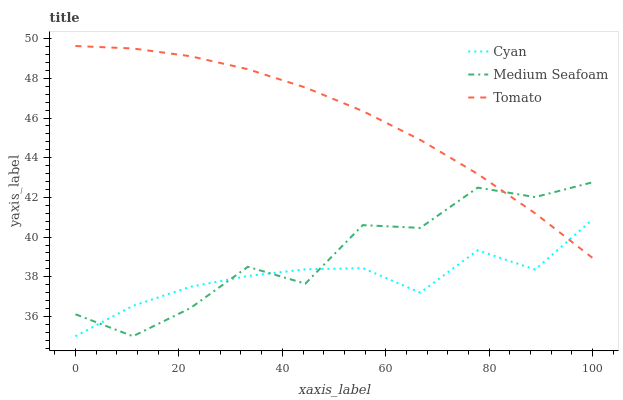Does Cyan have the minimum area under the curve?
Answer yes or no. Yes. Does Tomato have the maximum area under the curve?
Answer yes or no. Yes. Does Medium Seafoam have the minimum area under the curve?
Answer yes or no. No. Does Medium Seafoam have the maximum area under the curve?
Answer yes or no. No. Is Tomato the smoothest?
Answer yes or no. Yes. Is Medium Seafoam the roughest?
Answer yes or no. Yes. Is Cyan the smoothest?
Answer yes or no. No. Is Cyan the roughest?
Answer yes or no. No. Does Cyan have the lowest value?
Answer yes or no. Yes. Does Tomato have the highest value?
Answer yes or no. Yes. Does Medium Seafoam have the highest value?
Answer yes or no. No. Does Medium Seafoam intersect Tomato?
Answer yes or no. Yes. Is Medium Seafoam less than Tomato?
Answer yes or no. No. Is Medium Seafoam greater than Tomato?
Answer yes or no. No. 